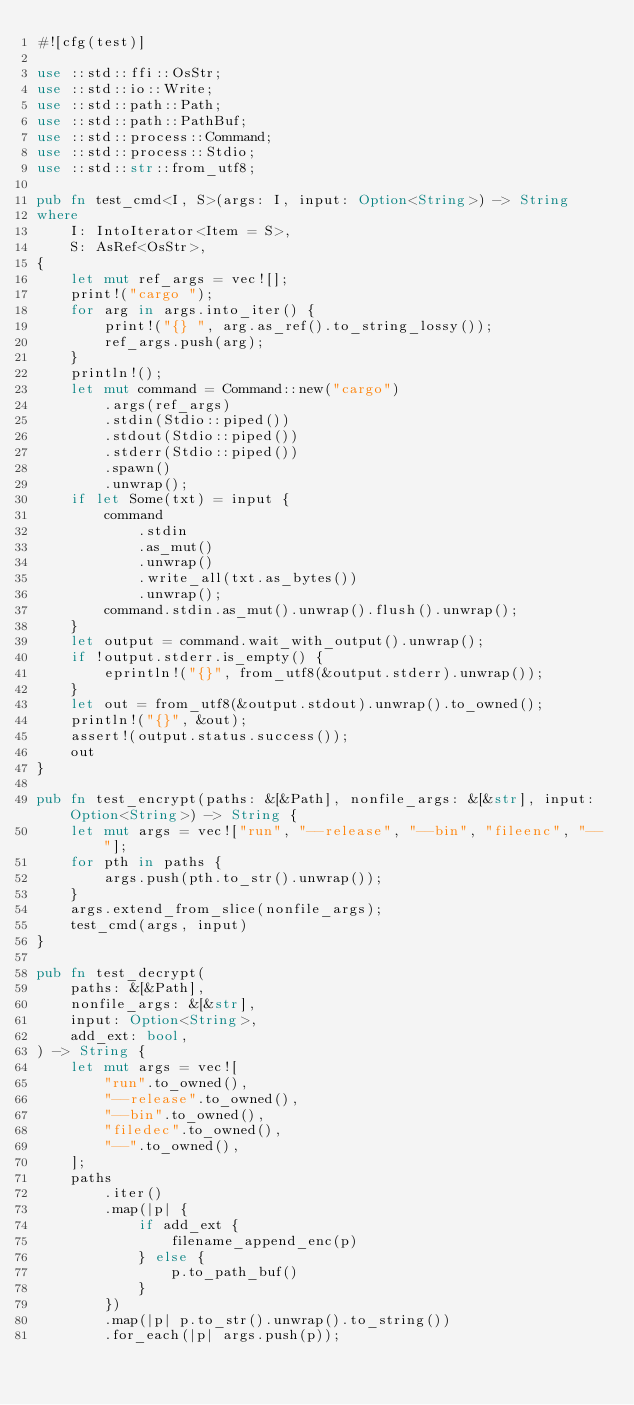<code> <loc_0><loc_0><loc_500><loc_500><_Rust_>#![cfg(test)]

use ::std::ffi::OsStr;
use ::std::io::Write;
use ::std::path::Path;
use ::std::path::PathBuf;
use ::std::process::Command;
use ::std::process::Stdio;
use ::std::str::from_utf8;

pub fn test_cmd<I, S>(args: I, input: Option<String>) -> String
where
    I: IntoIterator<Item = S>,
    S: AsRef<OsStr>,
{
    let mut ref_args = vec![];
    print!("cargo ");
    for arg in args.into_iter() {
        print!("{} ", arg.as_ref().to_string_lossy());
        ref_args.push(arg);
    }
    println!();
    let mut command = Command::new("cargo")
        .args(ref_args)
        .stdin(Stdio::piped())
        .stdout(Stdio::piped())
        .stderr(Stdio::piped())
        .spawn()
        .unwrap();
    if let Some(txt) = input {
        command
            .stdin
            .as_mut()
            .unwrap()
            .write_all(txt.as_bytes())
            .unwrap();
        command.stdin.as_mut().unwrap().flush().unwrap();
    }
    let output = command.wait_with_output().unwrap();
    if !output.stderr.is_empty() {
        eprintln!("{}", from_utf8(&output.stderr).unwrap());
    }
    let out = from_utf8(&output.stdout).unwrap().to_owned();
    println!("{}", &out);
    assert!(output.status.success());
    out
}

pub fn test_encrypt(paths: &[&Path], nonfile_args: &[&str], input: Option<String>) -> String {
    let mut args = vec!["run", "--release", "--bin", "fileenc", "--"];
    for pth in paths {
        args.push(pth.to_str().unwrap());
    }
    args.extend_from_slice(nonfile_args);
    test_cmd(args, input)
}

pub fn test_decrypt(
    paths: &[&Path],
    nonfile_args: &[&str],
    input: Option<String>,
    add_ext: bool,
) -> String {
    let mut args = vec![
        "run".to_owned(),
        "--release".to_owned(),
        "--bin".to_owned(),
        "filedec".to_owned(),
        "--".to_owned(),
    ];
    paths
        .iter()
        .map(|p| {
            if add_ext {
                filename_append_enc(p)
            } else {
                p.to_path_buf()
            }
        })
        .map(|p| p.to_str().unwrap().to_string())
        .for_each(|p| args.push(p));</code> 